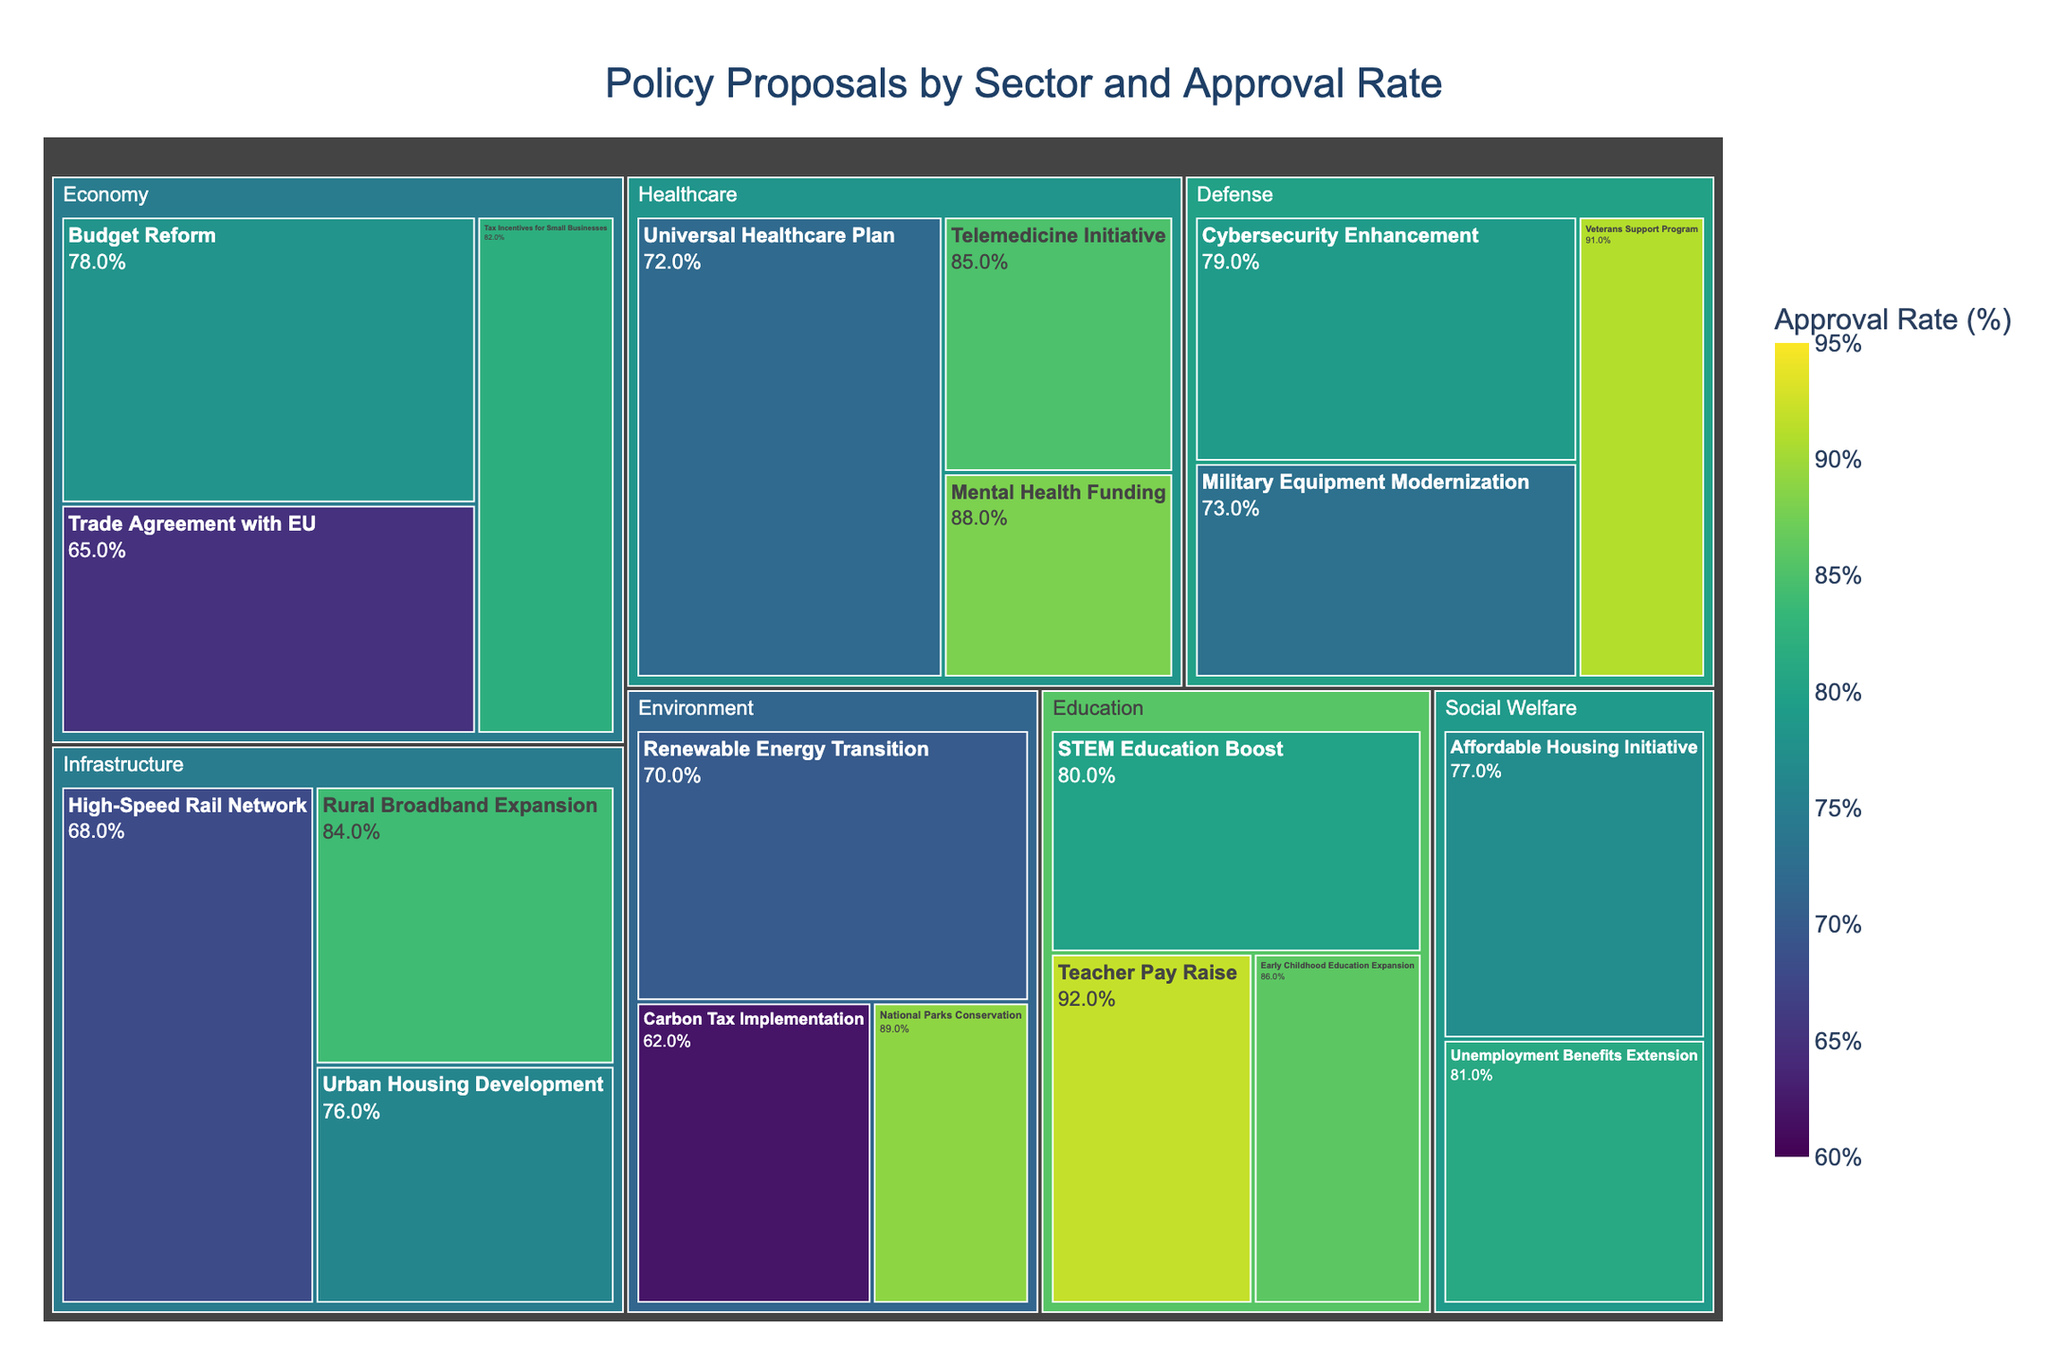How many policy proposals are there in the 'Healthcare' sector? To answer this question, look at the 'Healthcare' section in the treemap and count the individual policy proposals listed under this sector.
Answer: 3 Which policy proposal has the highest approval rate in the 'Economy' sector? Look under the 'Economy' sector in the treemap to find each policy proposal and their respective approval rates. Identify the proposal with the highest percentage.
Answer: Tax Incentives for Small Businesses What is the size difference between the 'Universal Healthcare Plan' and the 'Mental Health Funding' proposals? Locate both the 'Universal Healthcare Plan' and the 'Mental Health Funding' proposals in the 'Healthcare' sector. Note their sizes and subtract the smaller size from the larger size (60 - 20 = 40).
Answer: 40 Which sector has the proposal with the lowest approval rate? Examine the approval rates of proposals in each sector. Compare to find the lowest approval rate.
Answer: Environment (Carbon Tax Implementation) What is the average approval rate of policy proposals in the 'Education' sector? Find all approval rates in the 'Education' sector: 80, 92, and 86. Sum them up (80 + 92 + 86 = 258) and then divide by the number of proposals (3) to get the average (258 / 3 = 86).
Answer: 86 Which sector appears to focus the most on infrastructure improvements? Look for the sector with the most proposals related to infrastructure development (High-Speed Rail Network, Rural Broadband Expansion, Urban Housing Development).
Answer: Infrastructure What is the approval rate difference between the 'National Parks Conservation' and the 'Carbon Tax Implementation' proposals? Find the approval rates of 'National Parks Conservation' (89%) and 'Carbon Tax Implementation' (62%). Subtract the lower rate from the higher rate (89 - 62).
Answer: 27 How many policy proposals in total have an approval rate above 80%? Identify all proposals with approval rates above 80%. Count these proposals across all sectors: Tax Incentives for Small Businesses, Telemedicine Initiative, Mental Health Funding, Teacher Pay Raise, Early Childhood Education Expansion, National Parks Conservation, Rural Broadband Expansion, Veterans Support Program (8 proposals).
Answer: 8 What is the total size of proposals in the 'Defense' sector? Locate the sizes of proposals in the 'Defense' sector: 40, 25, and 35. Sum these sizes to get the total size (40 + 25 + 35 = 100).
Answer: 100 Which sector has the proposal with the highest size and what is that proposal? Look for the proposal with the highest size across all sectors. Find which sector it belongs to and its name. The highest size is 60 under 'Healthcare' (Universal Healthcare Plan).
Answer: Healthcare, Universal Healthcare Plan 